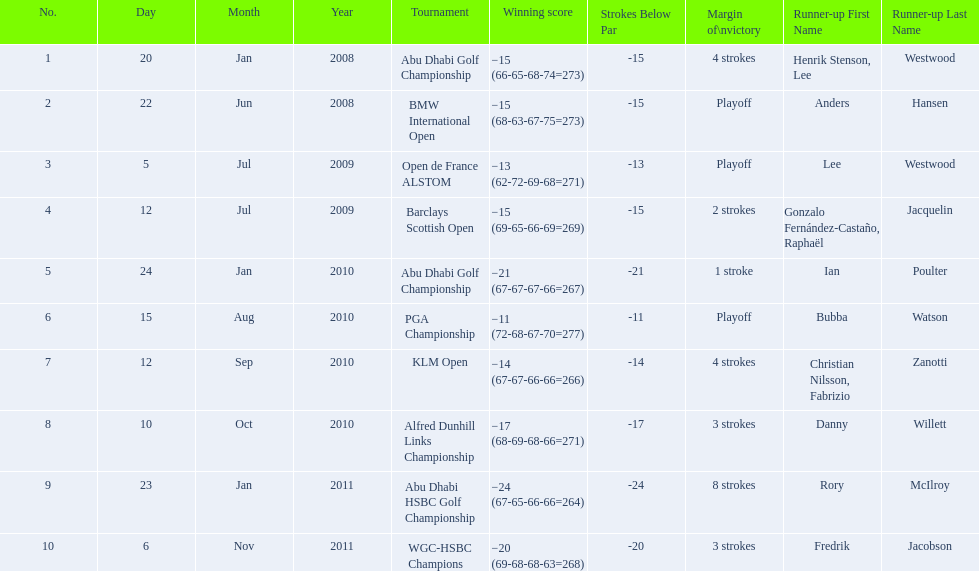Who had the top score in the pga championship? Bubba Watson. 